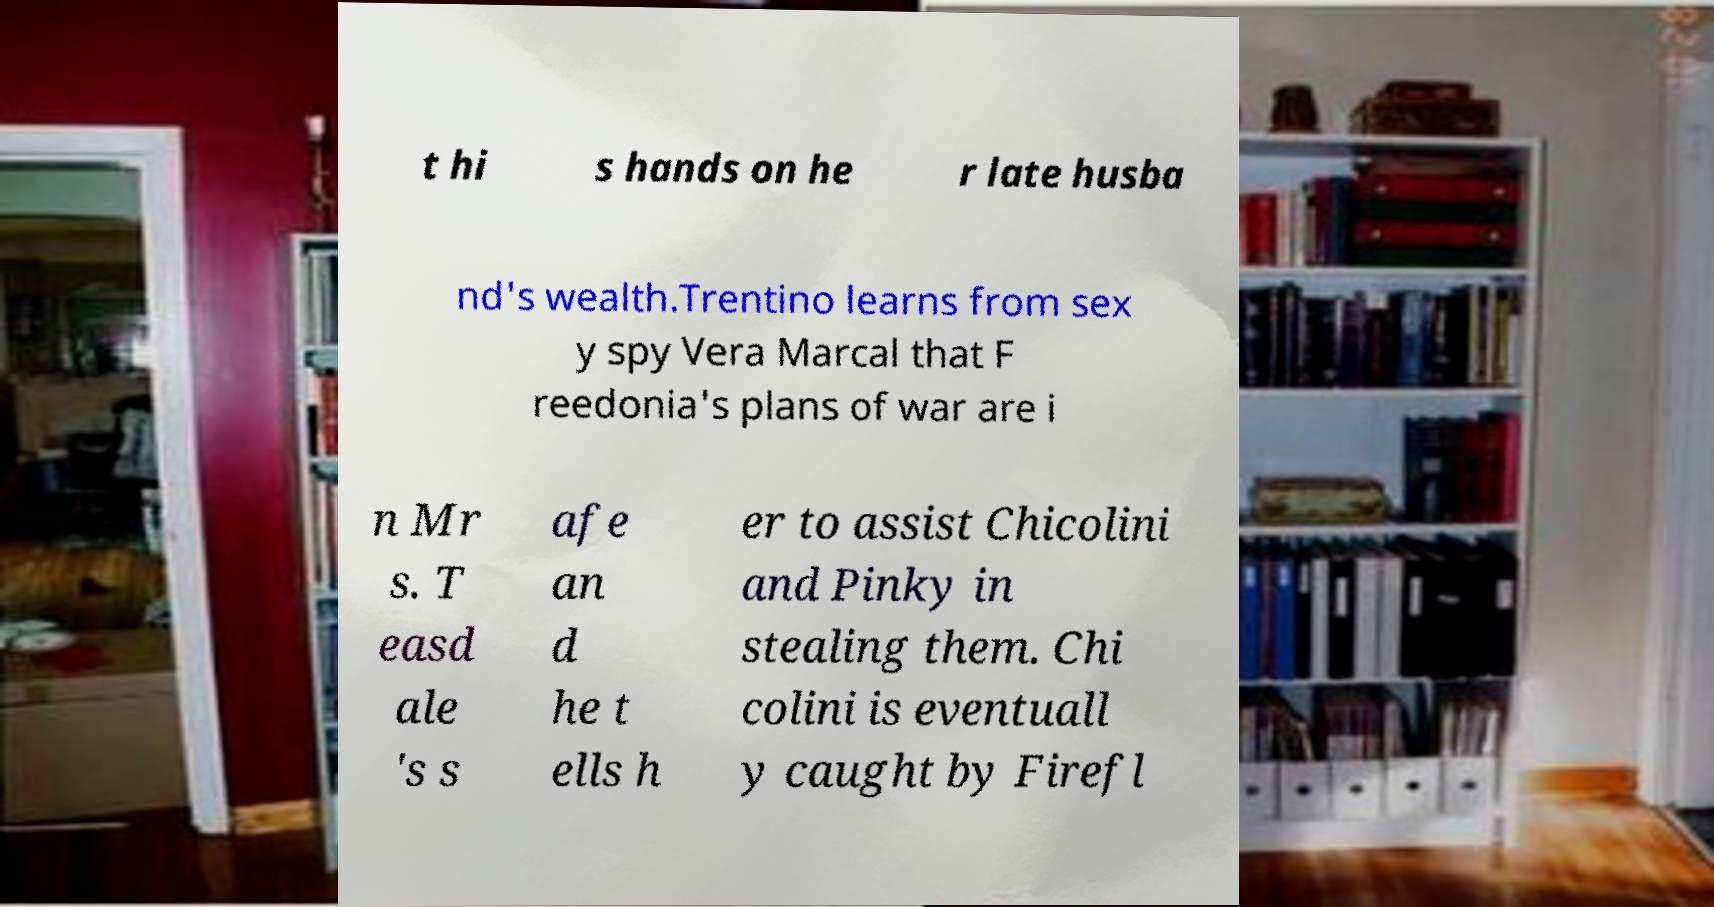I need the written content from this picture converted into text. Can you do that? t hi s hands on he r late husba nd's wealth.Trentino learns from sex y spy Vera Marcal that F reedonia's plans of war are i n Mr s. T easd ale 's s afe an d he t ells h er to assist Chicolini and Pinky in stealing them. Chi colini is eventuall y caught by Firefl 